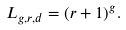Convert formula to latex. <formula><loc_0><loc_0><loc_500><loc_500>L _ { g , r , d } = ( r + 1 ) ^ { g } .</formula> 